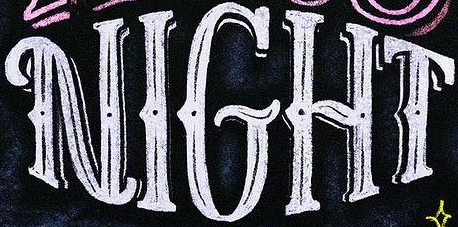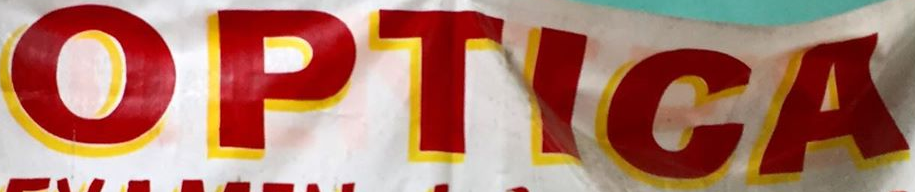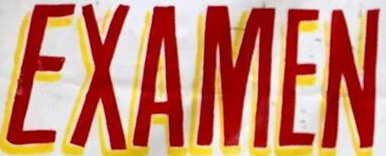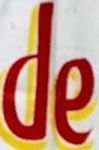Transcribe the words shown in these images in order, separated by a semicolon. NIGHT; OPTICA; EXAMEN; de 